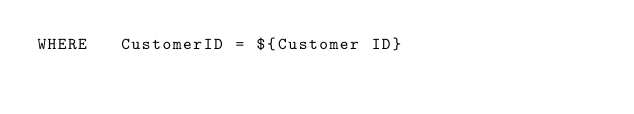Convert code to text. <code><loc_0><loc_0><loc_500><loc_500><_SQL_>WHERE	CustomerID = ${Customer ID}
</code> 